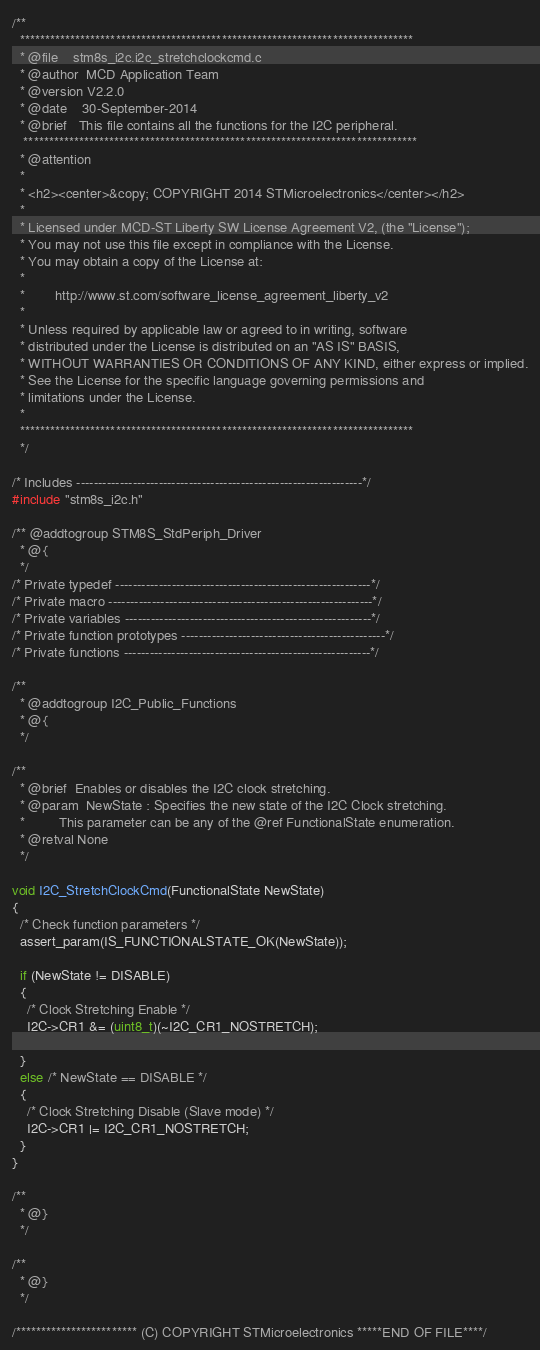<code> <loc_0><loc_0><loc_500><loc_500><_C_>/**
  ******************************************************************************
  * @file    stm8s_i2c.i2c_stretchclockcmd.c
  * @author  MCD Application Team
  * @version V2.2.0
  * @date    30-September-2014
  * @brief   This file contains all the functions for the I2C peripheral.
   ******************************************************************************
  * @attention
  *
  * <h2><center>&copy; COPYRIGHT 2014 STMicroelectronics</center></h2>
  *
  * Licensed under MCD-ST Liberty SW License Agreement V2, (the "License");
  * You may not use this file except in compliance with the License.
  * You may obtain a copy of the License at:
  *
  *        http://www.st.com/software_license_agreement_liberty_v2
  *
  * Unless required by applicable law or agreed to in writing, software 
  * distributed under the License is distributed on an "AS IS" BASIS, 
  * WITHOUT WARRANTIES OR CONDITIONS OF ANY KIND, either express or implied.
  * See the License for the specific language governing permissions and
  * limitations under the License.
  *
  ******************************************************************************
  */

/* Includes ------------------------------------------------------------------*/
#include "stm8s_i2c.h"

/** @addtogroup STM8S_StdPeriph_Driver
  * @{
  */
/* Private typedef -----------------------------------------------------------*/
/* Private macro -------------------------------------------------------------*/
/* Private variables ---------------------------------------------------------*/
/* Private function prototypes -----------------------------------------------*/
/* Private functions ---------------------------------------------------------*/

/**
  * @addtogroup I2C_Public_Functions
  * @{
  */

/**
  * @brief  Enables or disables the I2C clock stretching.
  * @param  NewState : Specifies the new state of the I2C Clock stretching.
  *         This parameter can be any of the @ref FunctionalState enumeration.
  * @retval None
  */

void I2C_StretchClockCmd(FunctionalState NewState)
{
  /* Check function parameters */
  assert_param(IS_FUNCTIONALSTATE_OK(NewState));

  if (NewState != DISABLE)
  {
    /* Clock Stretching Enable */
    I2C->CR1 &= (uint8_t)(~I2C_CR1_NOSTRETCH);

  }
  else /* NewState == DISABLE */
  {
    /* Clock Stretching Disable (Slave mode) */
    I2C->CR1 |= I2C_CR1_NOSTRETCH;
  }
}

/**
  * @}
  */

/**
  * @}
  */

/************************ (C) COPYRIGHT STMicroelectronics *****END OF FILE****/
</code> 